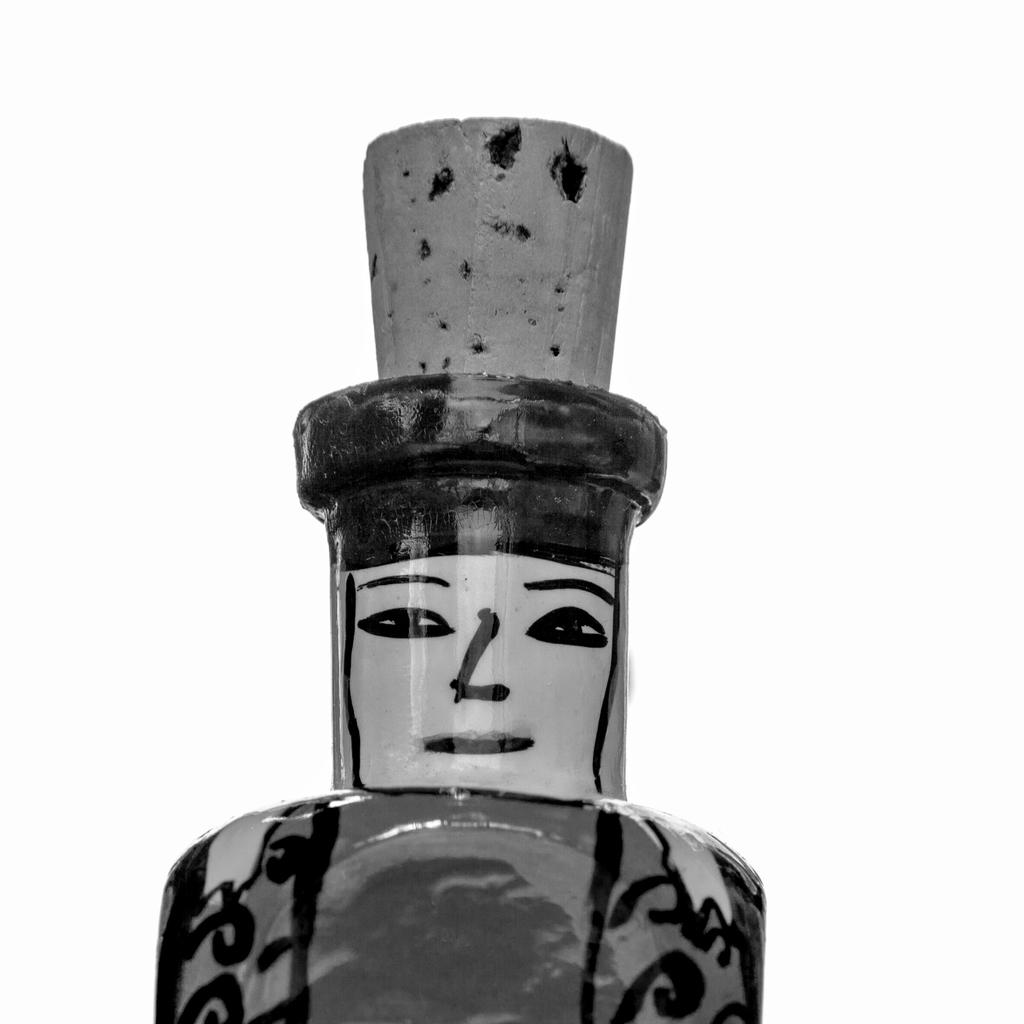What is the main subject in the center of the image? There is a toy in the center of the image. What type of footwear is the aunt wearing in the image? There is no aunt or footwear present in the image; it only features a toy in the center. 